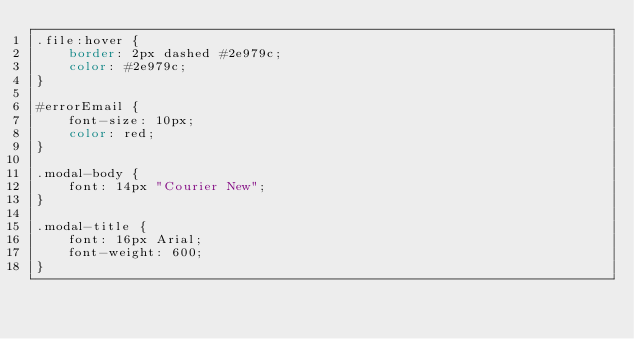Convert code to text. <code><loc_0><loc_0><loc_500><loc_500><_CSS_>.file:hover {
    border: 2px dashed #2e979c;
    color: #2e979c;
}

#errorEmail {
    font-size: 10px;
    color: red;
}

.modal-body {
    font: 14px "Courier New";
}

.modal-title {
    font: 16px Arial;
    font-weight: 600;
}
</code> 